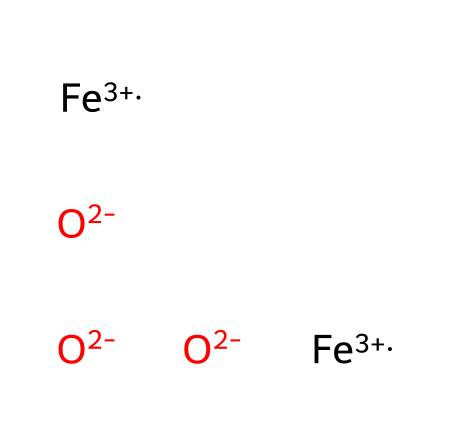What is the oxidation state of iron in this structure? The SMILES notation indicates the presence of [Fe+3], which shows iron is in the +3 oxidation state.
Answer: +3 How many oxygen atoms are present in this chemical structure? The structure contains three [O-2] entities, explicitly indicated in the SMILES.
Answer: 3 What is the total number of iron atoms in this structure? The SMILES shows two instances of [Fe+3], which indicates there are two iron atoms present in the structure.
Answer: 2 What type of bonding is likely present between iron and oxygen in iron oxide? Given the charged components ([Fe+3] and [O-2]), ionic bonding is expected between ions of opposite charges.
Answer: ionic What is the general classification of this compound? The presence of iron and oxygen suggests it is classified as an oxide, specifically an iron oxide.
Answer: oxide What role does iron oxide play in the durability of ancient Roman concrete? Iron oxide contributes to the binding and strength of the composite material, enhancing the durability of the concrete.
Answer: durability 